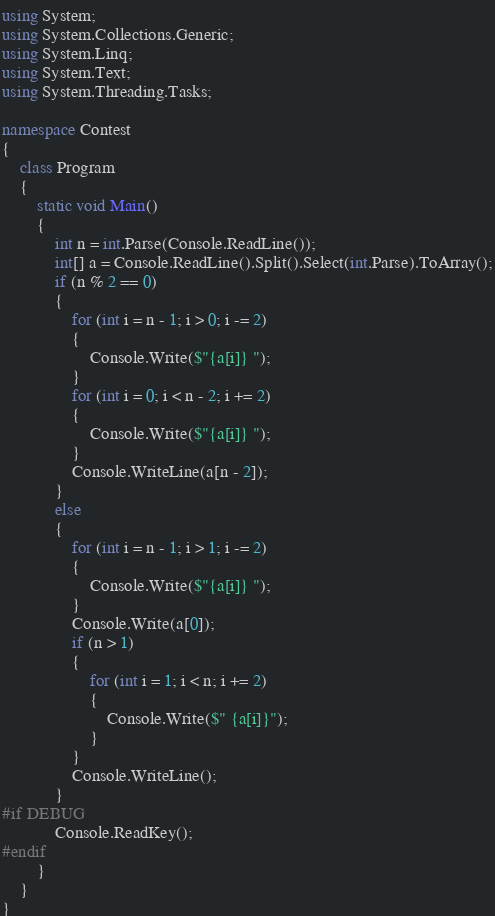<code> <loc_0><loc_0><loc_500><loc_500><_C#_>using System;
using System.Collections.Generic;
using System.Linq;
using System.Text;
using System.Threading.Tasks;

namespace Contest
{
	class Program
	{
		static void Main()
		{
            int n = int.Parse(Console.ReadLine());
            int[] a = Console.ReadLine().Split().Select(int.Parse).ToArray();
            if (n % 2 == 0)
            {
                for (int i = n - 1; i > 0; i -= 2)
                {
                    Console.Write($"{a[i]} ");
                }
                for (int i = 0; i < n - 2; i += 2)
                {
                    Console.Write($"{a[i]} ");
                }
                Console.WriteLine(a[n - 2]);
            }
            else
            {
                for (int i = n - 1; i > 1; i -= 2)
                {
                    Console.Write($"{a[i]} ");
                }
                Console.Write(a[0]);
                if (n > 1)
                {
                    for (int i = 1; i < n; i += 2)
                    {
                        Console.Write($" {a[i]}");
                    }
                }
                Console.WriteLine();
            }
#if DEBUG
            Console.ReadKey();
#endif
		}
	}
}</code> 